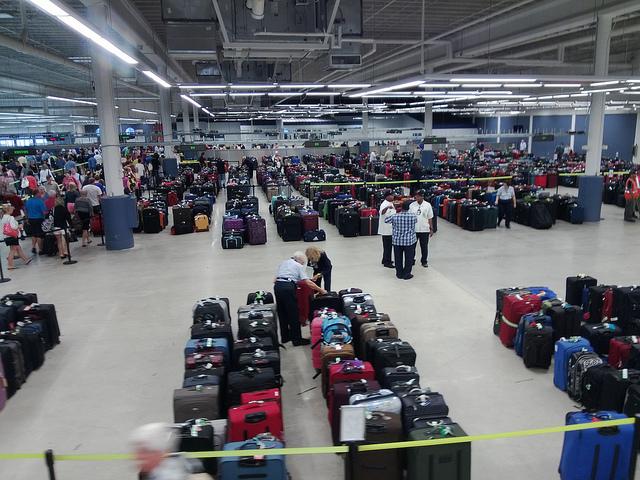What are there a lot of in this picture?
Keep it brief. Suitcases. How many bag luggages are seen?
Concise answer only. 400. What are the people in line on the far right waiting to do?
Quick response, please. Get luggage. 